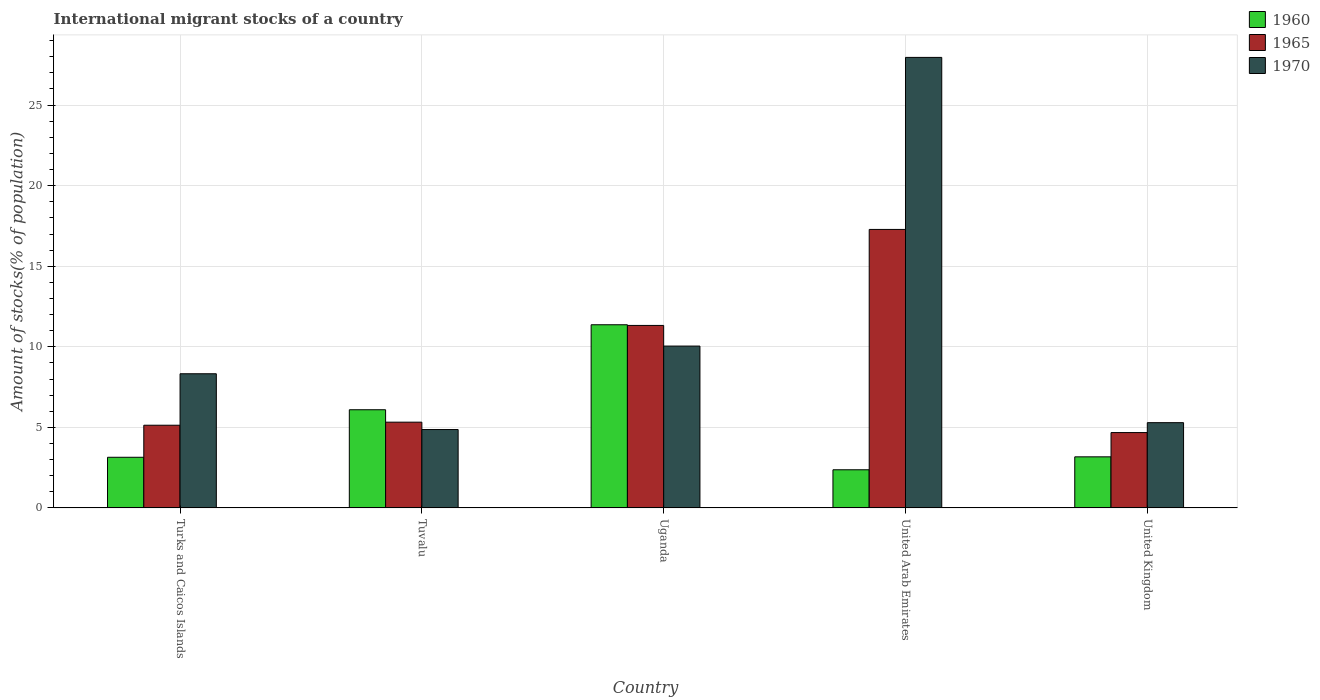How many bars are there on the 5th tick from the left?
Your response must be concise. 3. What is the label of the 3rd group of bars from the left?
Offer a terse response. Uganda. In how many cases, is the number of bars for a given country not equal to the number of legend labels?
Make the answer very short. 0. What is the amount of stocks in in 1965 in Tuvalu?
Offer a terse response. 5.32. Across all countries, what is the maximum amount of stocks in in 1960?
Provide a short and direct response. 11.37. Across all countries, what is the minimum amount of stocks in in 1960?
Provide a short and direct response. 2.37. In which country was the amount of stocks in in 1965 maximum?
Offer a very short reply. United Arab Emirates. In which country was the amount of stocks in in 1960 minimum?
Provide a succinct answer. United Arab Emirates. What is the total amount of stocks in in 1960 in the graph?
Give a very brief answer. 26.15. What is the difference between the amount of stocks in in 1965 in Tuvalu and that in United Kingdom?
Your answer should be compact. 0.65. What is the difference between the amount of stocks in in 1960 in Tuvalu and the amount of stocks in in 1965 in United Arab Emirates?
Provide a succinct answer. -11.19. What is the average amount of stocks in in 1960 per country?
Provide a succinct answer. 5.23. What is the difference between the amount of stocks in of/in 1960 and amount of stocks in of/in 1965 in Turks and Caicos Islands?
Provide a succinct answer. -1.99. In how many countries, is the amount of stocks in in 1960 greater than 24 %?
Provide a succinct answer. 0. What is the ratio of the amount of stocks in in 1960 in Tuvalu to that in United Arab Emirates?
Provide a short and direct response. 2.57. What is the difference between the highest and the second highest amount of stocks in in 1970?
Your response must be concise. -1.72. What is the difference between the highest and the lowest amount of stocks in in 1960?
Offer a terse response. 9. In how many countries, is the amount of stocks in in 1965 greater than the average amount of stocks in in 1965 taken over all countries?
Offer a very short reply. 2. Are all the bars in the graph horizontal?
Your answer should be very brief. No. What is the difference between two consecutive major ticks on the Y-axis?
Give a very brief answer. 5. Does the graph contain grids?
Make the answer very short. Yes. What is the title of the graph?
Make the answer very short. International migrant stocks of a country. What is the label or title of the Y-axis?
Make the answer very short. Amount of stocks(% of population). What is the Amount of stocks(% of population) of 1960 in Turks and Caicos Islands?
Provide a succinct answer. 3.14. What is the Amount of stocks(% of population) in 1965 in Turks and Caicos Islands?
Provide a succinct answer. 5.13. What is the Amount of stocks(% of population) in 1970 in Turks and Caicos Islands?
Provide a succinct answer. 8.33. What is the Amount of stocks(% of population) of 1960 in Tuvalu?
Your answer should be very brief. 6.09. What is the Amount of stocks(% of population) of 1965 in Tuvalu?
Make the answer very short. 5.32. What is the Amount of stocks(% of population) in 1970 in Tuvalu?
Your answer should be compact. 4.87. What is the Amount of stocks(% of population) in 1960 in Uganda?
Keep it short and to the point. 11.37. What is the Amount of stocks(% of population) of 1965 in Uganda?
Give a very brief answer. 11.33. What is the Amount of stocks(% of population) in 1970 in Uganda?
Keep it short and to the point. 10.05. What is the Amount of stocks(% of population) in 1960 in United Arab Emirates?
Keep it short and to the point. 2.37. What is the Amount of stocks(% of population) of 1965 in United Arab Emirates?
Keep it short and to the point. 17.28. What is the Amount of stocks(% of population) of 1970 in United Arab Emirates?
Provide a succinct answer. 27.96. What is the Amount of stocks(% of population) in 1960 in United Kingdom?
Offer a terse response. 3.17. What is the Amount of stocks(% of population) in 1965 in United Kingdom?
Make the answer very short. 4.68. What is the Amount of stocks(% of population) in 1970 in United Kingdom?
Your answer should be very brief. 5.29. Across all countries, what is the maximum Amount of stocks(% of population) of 1960?
Your response must be concise. 11.37. Across all countries, what is the maximum Amount of stocks(% of population) of 1965?
Offer a very short reply. 17.28. Across all countries, what is the maximum Amount of stocks(% of population) in 1970?
Offer a very short reply. 27.96. Across all countries, what is the minimum Amount of stocks(% of population) of 1960?
Offer a very short reply. 2.37. Across all countries, what is the minimum Amount of stocks(% of population) of 1965?
Provide a succinct answer. 4.68. Across all countries, what is the minimum Amount of stocks(% of population) in 1970?
Ensure brevity in your answer.  4.87. What is the total Amount of stocks(% of population) of 1960 in the graph?
Give a very brief answer. 26.15. What is the total Amount of stocks(% of population) in 1965 in the graph?
Give a very brief answer. 43.74. What is the total Amount of stocks(% of population) in 1970 in the graph?
Ensure brevity in your answer.  56.49. What is the difference between the Amount of stocks(% of population) in 1960 in Turks and Caicos Islands and that in Tuvalu?
Your answer should be compact. -2.95. What is the difference between the Amount of stocks(% of population) of 1965 in Turks and Caicos Islands and that in Tuvalu?
Provide a short and direct response. -0.19. What is the difference between the Amount of stocks(% of population) in 1970 in Turks and Caicos Islands and that in Tuvalu?
Provide a succinct answer. 3.46. What is the difference between the Amount of stocks(% of population) of 1960 in Turks and Caicos Islands and that in Uganda?
Your answer should be very brief. -8.22. What is the difference between the Amount of stocks(% of population) in 1965 in Turks and Caicos Islands and that in Uganda?
Keep it short and to the point. -6.19. What is the difference between the Amount of stocks(% of population) in 1970 in Turks and Caicos Islands and that in Uganda?
Provide a succinct answer. -1.72. What is the difference between the Amount of stocks(% of population) of 1960 in Turks and Caicos Islands and that in United Arab Emirates?
Keep it short and to the point. 0.78. What is the difference between the Amount of stocks(% of population) in 1965 in Turks and Caicos Islands and that in United Arab Emirates?
Make the answer very short. -12.15. What is the difference between the Amount of stocks(% of population) in 1970 in Turks and Caicos Islands and that in United Arab Emirates?
Offer a very short reply. -19.63. What is the difference between the Amount of stocks(% of population) of 1960 in Turks and Caicos Islands and that in United Kingdom?
Make the answer very short. -0.03. What is the difference between the Amount of stocks(% of population) in 1965 in Turks and Caicos Islands and that in United Kingdom?
Provide a succinct answer. 0.46. What is the difference between the Amount of stocks(% of population) of 1970 in Turks and Caicos Islands and that in United Kingdom?
Offer a very short reply. 3.04. What is the difference between the Amount of stocks(% of population) of 1960 in Tuvalu and that in Uganda?
Keep it short and to the point. -5.27. What is the difference between the Amount of stocks(% of population) of 1965 in Tuvalu and that in Uganda?
Your answer should be compact. -6. What is the difference between the Amount of stocks(% of population) in 1970 in Tuvalu and that in Uganda?
Offer a very short reply. -5.18. What is the difference between the Amount of stocks(% of population) of 1960 in Tuvalu and that in United Arab Emirates?
Ensure brevity in your answer.  3.73. What is the difference between the Amount of stocks(% of population) in 1965 in Tuvalu and that in United Arab Emirates?
Your answer should be compact. -11.96. What is the difference between the Amount of stocks(% of population) in 1970 in Tuvalu and that in United Arab Emirates?
Keep it short and to the point. -23.09. What is the difference between the Amount of stocks(% of population) of 1960 in Tuvalu and that in United Kingdom?
Make the answer very short. 2.92. What is the difference between the Amount of stocks(% of population) in 1965 in Tuvalu and that in United Kingdom?
Provide a succinct answer. 0.65. What is the difference between the Amount of stocks(% of population) of 1970 in Tuvalu and that in United Kingdom?
Give a very brief answer. -0.43. What is the difference between the Amount of stocks(% of population) of 1960 in Uganda and that in United Arab Emirates?
Your answer should be very brief. 9. What is the difference between the Amount of stocks(% of population) of 1965 in Uganda and that in United Arab Emirates?
Offer a very short reply. -5.96. What is the difference between the Amount of stocks(% of population) of 1970 in Uganda and that in United Arab Emirates?
Provide a succinct answer. -17.91. What is the difference between the Amount of stocks(% of population) of 1960 in Uganda and that in United Kingdom?
Ensure brevity in your answer.  8.2. What is the difference between the Amount of stocks(% of population) in 1965 in Uganda and that in United Kingdom?
Your answer should be compact. 6.65. What is the difference between the Amount of stocks(% of population) of 1970 in Uganda and that in United Kingdom?
Give a very brief answer. 4.75. What is the difference between the Amount of stocks(% of population) in 1960 in United Arab Emirates and that in United Kingdom?
Provide a succinct answer. -0.8. What is the difference between the Amount of stocks(% of population) of 1965 in United Arab Emirates and that in United Kingdom?
Ensure brevity in your answer.  12.61. What is the difference between the Amount of stocks(% of population) of 1970 in United Arab Emirates and that in United Kingdom?
Offer a terse response. 22.67. What is the difference between the Amount of stocks(% of population) of 1960 in Turks and Caicos Islands and the Amount of stocks(% of population) of 1965 in Tuvalu?
Offer a terse response. -2.18. What is the difference between the Amount of stocks(% of population) in 1960 in Turks and Caicos Islands and the Amount of stocks(% of population) in 1970 in Tuvalu?
Provide a short and direct response. -1.72. What is the difference between the Amount of stocks(% of population) of 1965 in Turks and Caicos Islands and the Amount of stocks(% of population) of 1970 in Tuvalu?
Keep it short and to the point. 0.27. What is the difference between the Amount of stocks(% of population) in 1960 in Turks and Caicos Islands and the Amount of stocks(% of population) in 1965 in Uganda?
Your answer should be very brief. -8.18. What is the difference between the Amount of stocks(% of population) of 1960 in Turks and Caicos Islands and the Amount of stocks(% of population) of 1970 in Uganda?
Your answer should be very brief. -6.9. What is the difference between the Amount of stocks(% of population) of 1965 in Turks and Caicos Islands and the Amount of stocks(% of population) of 1970 in Uganda?
Provide a short and direct response. -4.91. What is the difference between the Amount of stocks(% of population) in 1960 in Turks and Caicos Islands and the Amount of stocks(% of population) in 1965 in United Arab Emirates?
Provide a short and direct response. -14.14. What is the difference between the Amount of stocks(% of population) of 1960 in Turks and Caicos Islands and the Amount of stocks(% of population) of 1970 in United Arab Emirates?
Ensure brevity in your answer.  -24.82. What is the difference between the Amount of stocks(% of population) of 1965 in Turks and Caicos Islands and the Amount of stocks(% of population) of 1970 in United Arab Emirates?
Your answer should be compact. -22.83. What is the difference between the Amount of stocks(% of population) in 1960 in Turks and Caicos Islands and the Amount of stocks(% of population) in 1965 in United Kingdom?
Provide a succinct answer. -1.53. What is the difference between the Amount of stocks(% of population) of 1960 in Turks and Caicos Islands and the Amount of stocks(% of population) of 1970 in United Kingdom?
Keep it short and to the point. -2.15. What is the difference between the Amount of stocks(% of population) in 1965 in Turks and Caicos Islands and the Amount of stocks(% of population) in 1970 in United Kingdom?
Offer a very short reply. -0.16. What is the difference between the Amount of stocks(% of population) in 1960 in Tuvalu and the Amount of stocks(% of population) in 1965 in Uganda?
Give a very brief answer. -5.23. What is the difference between the Amount of stocks(% of population) in 1960 in Tuvalu and the Amount of stocks(% of population) in 1970 in Uganda?
Keep it short and to the point. -3.95. What is the difference between the Amount of stocks(% of population) in 1965 in Tuvalu and the Amount of stocks(% of population) in 1970 in Uganda?
Provide a succinct answer. -4.72. What is the difference between the Amount of stocks(% of population) in 1960 in Tuvalu and the Amount of stocks(% of population) in 1965 in United Arab Emirates?
Offer a terse response. -11.19. What is the difference between the Amount of stocks(% of population) in 1960 in Tuvalu and the Amount of stocks(% of population) in 1970 in United Arab Emirates?
Your response must be concise. -21.87. What is the difference between the Amount of stocks(% of population) of 1965 in Tuvalu and the Amount of stocks(% of population) of 1970 in United Arab Emirates?
Your answer should be compact. -22.64. What is the difference between the Amount of stocks(% of population) of 1960 in Tuvalu and the Amount of stocks(% of population) of 1965 in United Kingdom?
Ensure brevity in your answer.  1.42. What is the difference between the Amount of stocks(% of population) in 1960 in Tuvalu and the Amount of stocks(% of population) in 1970 in United Kingdom?
Your response must be concise. 0.8. What is the difference between the Amount of stocks(% of population) in 1965 in Tuvalu and the Amount of stocks(% of population) in 1970 in United Kingdom?
Your response must be concise. 0.03. What is the difference between the Amount of stocks(% of population) of 1960 in Uganda and the Amount of stocks(% of population) of 1965 in United Arab Emirates?
Provide a short and direct response. -5.92. What is the difference between the Amount of stocks(% of population) in 1960 in Uganda and the Amount of stocks(% of population) in 1970 in United Arab Emirates?
Offer a terse response. -16.59. What is the difference between the Amount of stocks(% of population) in 1965 in Uganda and the Amount of stocks(% of population) in 1970 in United Arab Emirates?
Offer a terse response. -16.63. What is the difference between the Amount of stocks(% of population) in 1960 in Uganda and the Amount of stocks(% of population) in 1965 in United Kingdom?
Your answer should be compact. 6.69. What is the difference between the Amount of stocks(% of population) of 1960 in Uganda and the Amount of stocks(% of population) of 1970 in United Kingdom?
Provide a short and direct response. 6.08. What is the difference between the Amount of stocks(% of population) in 1965 in Uganda and the Amount of stocks(% of population) in 1970 in United Kingdom?
Your answer should be very brief. 6.03. What is the difference between the Amount of stocks(% of population) of 1960 in United Arab Emirates and the Amount of stocks(% of population) of 1965 in United Kingdom?
Keep it short and to the point. -2.31. What is the difference between the Amount of stocks(% of population) of 1960 in United Arab Emirates and the Amount of stocks(% of population) of 1970 in United Kingdom?
Give a very brief answer. -2.92. What is the difference between the Amount of stocks(% of population) of 1965 in United Arab Emirates and the Amount of stocks(% of population) of 1970 in United Kingdom?
Give a very brief answer. 11.99. What is the average Amount of stocks(% of population) of 1960 per country?
Provide a succinct answer. 5.23. What is the average Amount of stocks(% of population) in 1965 per country?
Offer a terse response. 8.75. What is the average Amount of stocks(% of population) in 1970 per country?
Give a very brief answer. 11.3. What is the difference between the Amount of stocks(% of population) in 1960 and Amount of stocks(% of population) in 1965 in Turks and Caicos Islands?
Offer a very short reply. -1.99. What is the difference between the Amount of stocks(% of population) in 1960 and Amount of stocks(% of population) in 1970 in Turks and Caicos Islands?
Offer a terse response. -5.18. What is the difference between the Amount of stocks(% of population) in 1965 and Amount of stocks(% of population) in 1970 in Turks and Caicos Islands?
Ensure brevity in your answer.  -3.19. What is the difference between the Amount of stocks(% of population) of 1960 and Amount of stocks(% of population) of 1965 in Tuvalu?
Your answer should be very brief. 0.77. What is the difference between the Amount of stocks(% of population) in 1960 and Amount of stocks(% of population) in 1970 in Tuvalu?
Your answer should be compact. 1.23. What is the difference between the Amount of stocks(% of population) of 1965 and Amount of stocks(% of population) of 1970 in Tuvalu?
Your response must be concise. 0.46. What is the difference between the Amount of stocks(% of population) in 1960 and Amount of stocks(% of population) in 1965 in Uganda?
Your answer should be very brief. 0.04. What is the difference between the Amount of stocks(% of population) of 1960 and Amount of stocks(% of population) of 1970 in Uganda?
Provide a short and direct response. 1.32. What is the difference between the Amount of stocks(% of population) in 1965 and Amount of stocks(% of population) in 1970 in Uganda?
Ensure brevity in your answer.  1.28. What is the difference between the Amount of stocks(% of population) of 1960 and Amount of stocks(% of population) of 1965 in United Arab Emirates?
Your answer should be compact. -14.91. What is the difference between the Amount of stocks(% of population) in 1960 and Amount of stocks(% of population) in 1970 in United Arab Emirates?
Offer a very short reply. -25.59. What is the difference between the Amount of stocks(% of population) of 1965 and Amount of stocks(% of population) of 1970 in United Arab Emirates?
Your response must be concise. -10.68. What is the difference between the Amount of stocks(% of population) of 1960 and Amount of stocks(% of population) of 1965 in United Kingdom?
Keep it short and to the point. -1.51. What is the difference between the Amount of stocks(% of population) of 1960 and Amount of stocks(% of population) of 1970 in United Kingdom?
Your answer should be compact. -2.12. What is the difference between the Amount of stocks(% of population) of 1965 and Amount of stocks(% of population) of 1970 in United Kingdom?
Keep it short and to the point. -0.62. What is the ratio of the Amount of stocks(% of population) of 1960 in Turks and Caicos Islands to that in Tuvalu?
Offer a terse response. 0.52. What is the ratio of the Amount of stocks(% of population) in 1965 in Turks and Caicos Islands to that in Tuvalu?
Offer a terse response. 0.96. What is the ratio of the Amount of stocks(% of population) of 1970 in Turks and Caicos Islands to that in Tuvalu?
Offer a very short reply. 1.71. What is the ratio of the Amount of stocks(% of population) of 1960 in Turks and Caicos Islands to that in Uganda?
Offer a very short reply. 0.28. What is the ratio of the Amount of stocks(% of population) of 1965 in Turks and Caicos Islands to that in Uganda?
Make the answer very short. 0.45. What is the ratio of the Amount of stocks(% of population) of 1970 in Turks and Caicos Islands to that in Uganda?
Your answer should be compact. 0.83. What is the ratio of the Amount of stocks(% of population) of 1960 in Turks and Caicos Islands to that in United Arab Emirates?
Offer a terse response. 1.33. What is the ratio of the Amount of stocks(% of population) in 1965 in Turks and Caicos Islands to that in United Arab Emirates?
Offer a terse response. 0.3. What is the ratio of the Amount of stocks(% of population) in 1970 in Turks and Caicos Islands to that in United Arab Emirates?
Your answer should be compact. 0.3. What is the ratio of the Amount of stocks(% of population) in 1960 in Turks and Caicos Islands to that in United Kingdom?
Offer a terse response. 0.99. What is the ratio of the Amount of stocks(% of population) in 1965 in Turks and Caicos Islands to that in United Kingdom?
Ensure brevity in your answer.  1.1. What is the ratio of the Amount of stocks(% of population) of 1970 in Turks and Caicos Islands to that in United Kingdom?
Provide a short and direct response. 1.57. What is the ratio of the Amount of stocks(% of population) of 1960 in Tuvalu to that in Uganda?
Provide a succinct answer. 0.54. What is the ratio of the Amount of stocks(% of population) of 1965 in Tuvalu to that in Uganda?
Offer a very short reply. 0.47. What is the ratio of the Amount of stocks(% of population) in 1970 in Tuvalu to that in Uganda?
Ensure brevity in your answer.  0.48. What is the ratio of the Amount of stocks(% of population) of 1960 in Tuvalu to that in United Arab Emirates?
Offer a terse response. 2.57. What is the ratio of the Amount of stocks(% of population) in 1965 in Tuvalu to that in United Arab Emirates?
Your response must be concise. 0.31. What is the ratio of the Amount of stocks(% of population) in 1970 in Tuvalu to that in United Arab Emirates?
Offer a very short reply. 0.17. What is the ratio of the Amount of stocks(% of population) in 1960 in Tuvalu to that in United Kingdom?
Your response must be concise. 1.92. What is the ratio of the Amount of stocks(% of population) in 1965 in Tuvalu to that in United Kingdom?
Provide a short and direct response. 1.14. What is the ratio of the Amount of stocks(% of population) of 1970 in Tuvalu to that in United Kingdom?
Offer a terse response. 0.92. What is the ratio of the Amount of stocks(% of population) in 1960 in Uganda to that in United Arab Emirates?
Give a very brief answer. 4.8. What is the ratio of the Amount of stocks(% of population) of 1965 in Uganda to that in United Arab Emirates?
Your answer should be very brief. 0.66. What is the ratio of the Amount of stocks(% of population) in 1970 in Uganda to that in United Arab Emirates?
Provide a short and direct response. 0.36. What is the ratio of the Amount of stocks(% of population) in 1960 in Uganda to that in United Kingdom?
Ensure brevity in your answer.  3.58. What is the ratio of the Amount of stocks(% of population) of 1965 in Uganda to that in United Kingdom?
Your answer should be compact. 2.42. What is the ratio of the Amount of stocks(% of population) of 1970 in Uganda to that in United Kingdom?
Make the answer very short. 1.9. What is the ratio of the Amount of stocks(% of population) of 1960 in United Arab Emirates to that in United Kingdom?
Offer a terse response. 0.75. What is the ratio of the Amount of stocks(% of population) of 1965 in United Arab Emirates to that in United Kingdom?
Ensure brevity in your answer.  3.7. What is the ratio of the Amount of stocks(% of population) in 1970 in United Arab Emirates to that in United Kingdom?
Your answer should be compact. 5.28. What is the difference between the highest and the second highest Amount of stocks(% of population) of 1960?
Keep it short and to the point. 5.27. What is the difference between the highest and the second highest Amount of stocks(% of population) of 1965?
Your answer should be very brief. 5.96. What is the difference between the highest and the second highest Amount of stocks(% of population) of 1970?
Provide a succinct answer. 17.91. What is the difference between the highest and the lowest Amount of stocks(% of population) of 1960?
Give a very brief answer. 9. What is the difference between the highest and the lowest Amount of stocks(% of population) of 1965?
Provide a succinct answer. 12.61. What is the difference between the highest and the lowest Amount of stocks(% of population) in 1970?
Offer a terse response. 23.09. 